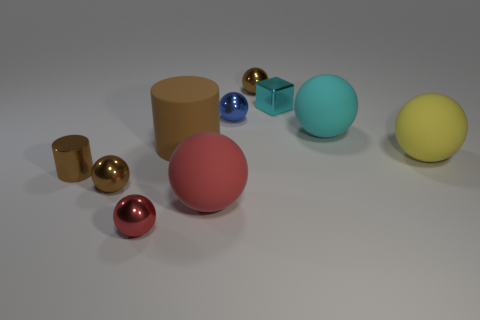What number of red objects are behind the metal cylinder?
Your response must be concise. 0. Does the large red rubber object have the same shape as the blue thing?
Your answer should be very brief. Yes. What number of objects are left of the cyan cube and right of the brown matte cylinder?
Ensure brevity in your answer.  3. What number of objects are cylinders or big matte spheres in front of the big cyan matte ball?
Your answer should be very brief. 4. Are there more green metal spheres than red rubber objects?
Provide a succinct answer. No. The small cyan object left of the large yellow rubber ball has what shape?
Keep it short and to the point. Cube. What number of other large brown matte objects are the same shape as the large brown thing?
Keep it short and to the point. 0. There is a brown metallic thing to the right of the small blue metallic ball that is on the left side of the small cyan shiny object; what is its size?
Keep it short and to the point. Small. What number of gray objects are either tiny cylinders or tiny shiny blocks?
Your answer should be very brief. 0. Is the number of tiny brown shiny things behind the tiny metal cylinder less than the number of blue shiny things in front of the large brown cylinder?
Give a very brief answer. No. 